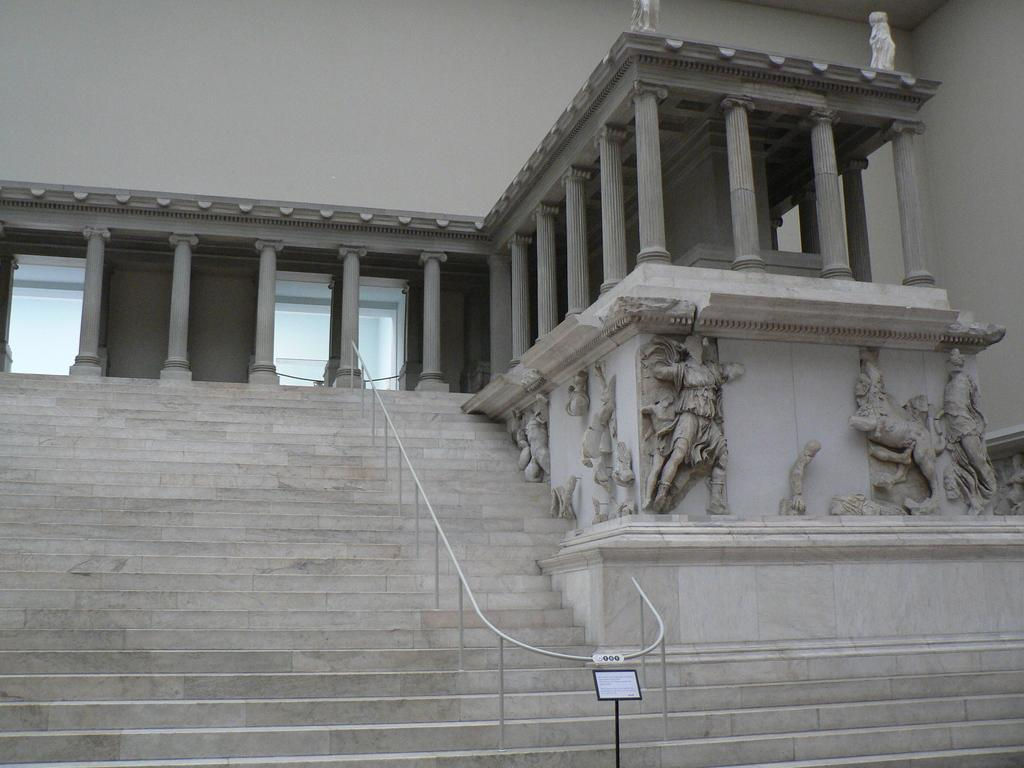What type of structure is visible in the image? There is a building in the image. What architectural features can be seen in the middle of the image? There are pillars in the middle of the image. What safety feature is present on the steps? There is a handrail on the steps. What type of artwork is on the right side of the image? There are sculptures on the right side of the image. How many drawers are visible in the image? There are no drawers present in the image. What type of head is depicted in the sculpture on the right side of the image? There is no head depicted in the sculpture on the right side of the image; it is a full-body sculpture. 